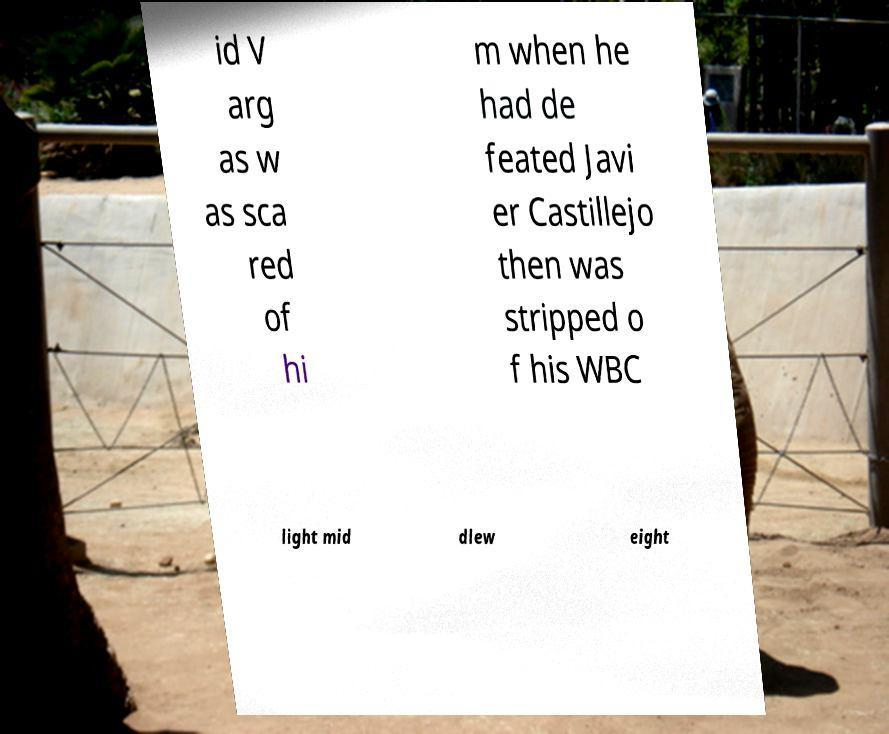What messages or text are displayed in this image? I need them in a readable, typed format. id V arg as w as sca red of hi m when he had de feated Javi er Castillejo then was stripped o f his WBC light mid dlew eight 